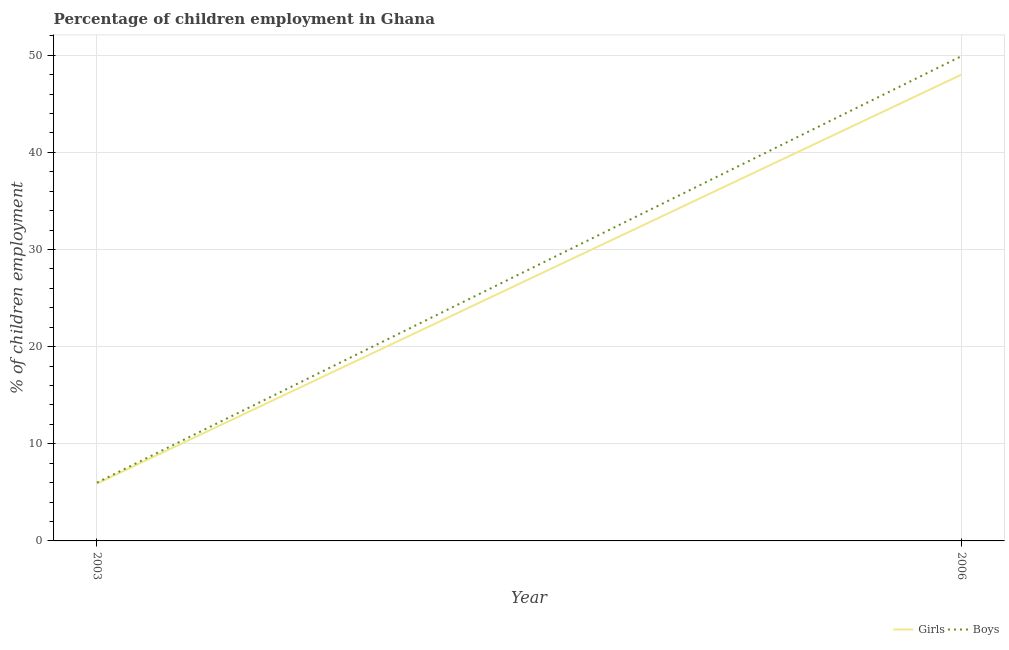Is the number of lines equal to the number of legend labels?
Keep it short and to the point. Yes. What is the percentage of employed girls in 2003?
Ensure brevity in your answer.  5.9. Across all years, what is the minimum percentage of employed boys?
Keep it short and to the point. 6. What is the total percentage of employed girls in the graph?
Your response must be concise. 53.9. What is the difference between the percentage of employed boys in 2003 and that in 2006?
Provide a short and direct response. -43.9. What is the difference between the percentage of employed boys in 2006 and the percentage of employed girls in 2003?
Your response must be concise. 44. What is the average percentage of employed boys per year?
Your answer should be compact. 27.95. In the year 2006, what is the difference between the percentage of employed girls and percentage of employed boys?
Your answer should be compact. -1.9. What is the ratio of the percentage of employed girls in 2003 to that in 2006?
Give a very brief answer. 0.12. Is the percentage of employed girls strictly greater than the percentage of employed boys over the years?
Ensure brevity in your answer.  No. Is the percentage of employed boys strictly less than the percentage of employed girls over the years?
Give a very brief answer. No. How many lines are there?
Give a very brief answer. 2. How many years are there in the graph?
Offer a very short reply. 2. What is the difference between two consecutive major ticks on the Y-axis?
Your answer should be compact. 10. Does the graph contain any zero values?
Provide a succinct answer. No. Where does the legend appear in the graph?
Keep it short and to the point. Bottom right. How many legend labels are there?
Offer a very short reply. 2. What is the title of the graph?
Your answer should be compact. Percentage of children employment in Ghana. What is the label or title of the Y-axis?
Provide a short and direct response. % of children employment. What is the % of children employment of Girls in 2006?
Offer a terse response. 48. What is the % of children employment of Boys in 2006?
Provide a short and direct response. 49.9. Across all years, what is the maximum % of children employment of Boys?
Keep it short and to the point. 49.9. Across all years, what is the minimum % of children employment of Girls?
Make the answer very short. 5.9. Across all years, what is the minimum % of children employment of Boys?
Your answer should be compact. 6. What is the total % of children employment in Girls in the graph?
Offer a terse response. 53.9. What is the total % of children employment in Boys in the graph?
Provide a succinct answer. 55.9. What is the difference between the % of children employment in Girls in 2003 and that in 2006?
Your answer should be very brief. -42.1. What is the difference between the % of children employment of Boys in 2003 and that in 2006?
Your answer should be compact. -43.9. What is the difference between the % of children employment in Girls in 2003 and the % of children employment in Boys in 2006?
Offer a very short reply. -44. What is the average % of children employment in Girls per year?
Your answer should be compact. 26.95. What is the average % of children employment in Boys per year?
Your answer should be very brief. 27.95. In the year 2006, what is the difference between the % of children employment in Girls and % of children employment in Boys?
Keep it short and to the point. -1.9. What is the ratio of the % of children employment of Girls in 2003 to that in 2006?
Make the answer very short. 0.12. What is the ratio of the % of children employment of Boys in 2003 to that in 2006?
Your response must be concise. 0.12. What is the difference between the highest and the second highest % of children employment in Girls?
Your response must be concise. 42.1. What is the difference between the highest and the second highest % of children employment in Boys?
Give a very brief answer. 43.9. What is the difference between the highest and the lowest % of children employment in Girls?
Give a very brief answer. 42.1. What is the difference between the highest and the lowest % of children employment in Boys?
Offer a very short reply. 43.9. 